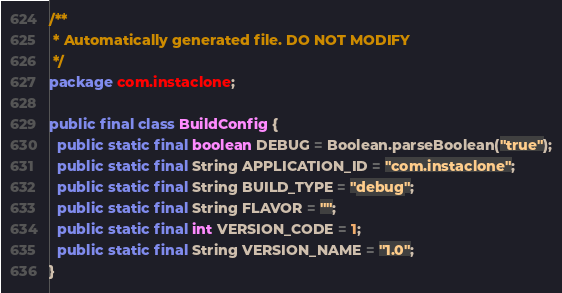<code> <loc_0><loc_0><loc_500><loc_500><_Java_>/**
 * Automatically generated file. DO NOT MODIFY
 */
package com.instaclone;

public final class BuildConfig {
  public static final boolean DEBUG = Boolean.parseBoolean("true");
  public static final String APPLICATION_ID = "com.instaclone";
  public static final String BUILD_TYPE = "debug";
  public static final String FLAVOR = "";
  public static final int VERSION_CODE = 1;
  public static final String VERSION_NAME = "1.0";
}
</code> 